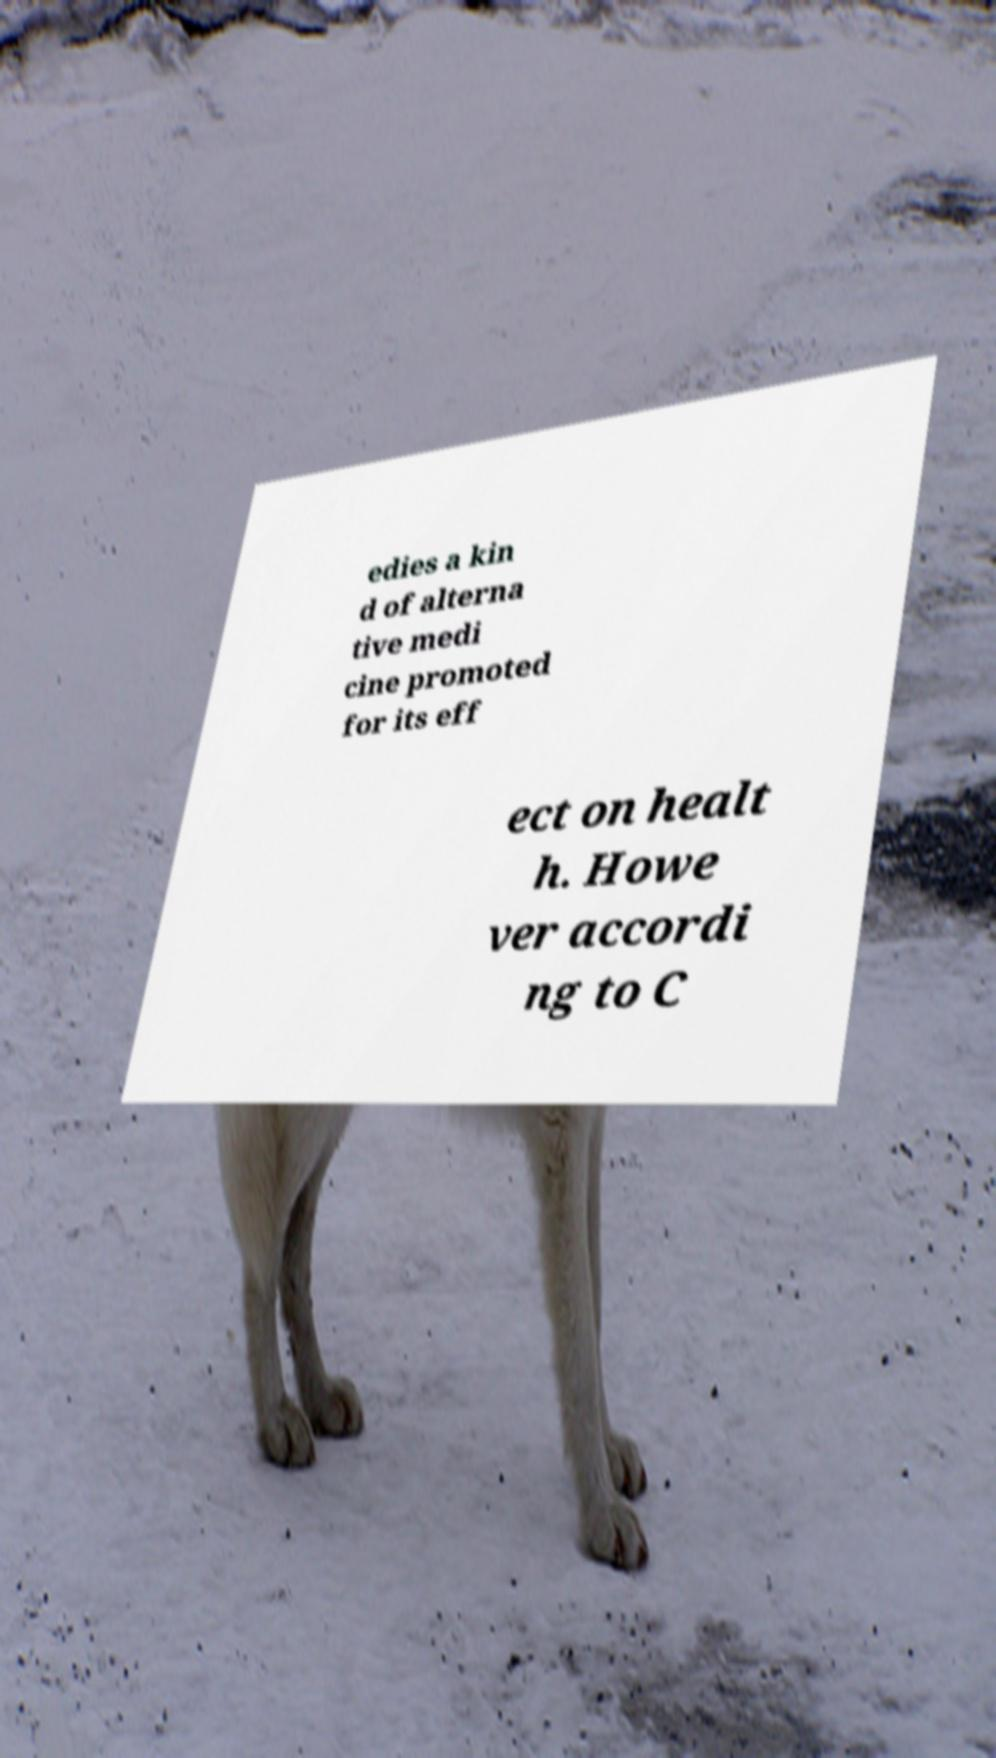For documentation purposes, I need the text within this image transcribed. Could you provide that? edies a kin d of alterna tive medi cine promoted for its eff ect on healt h. Howe ver accordi ng to C 